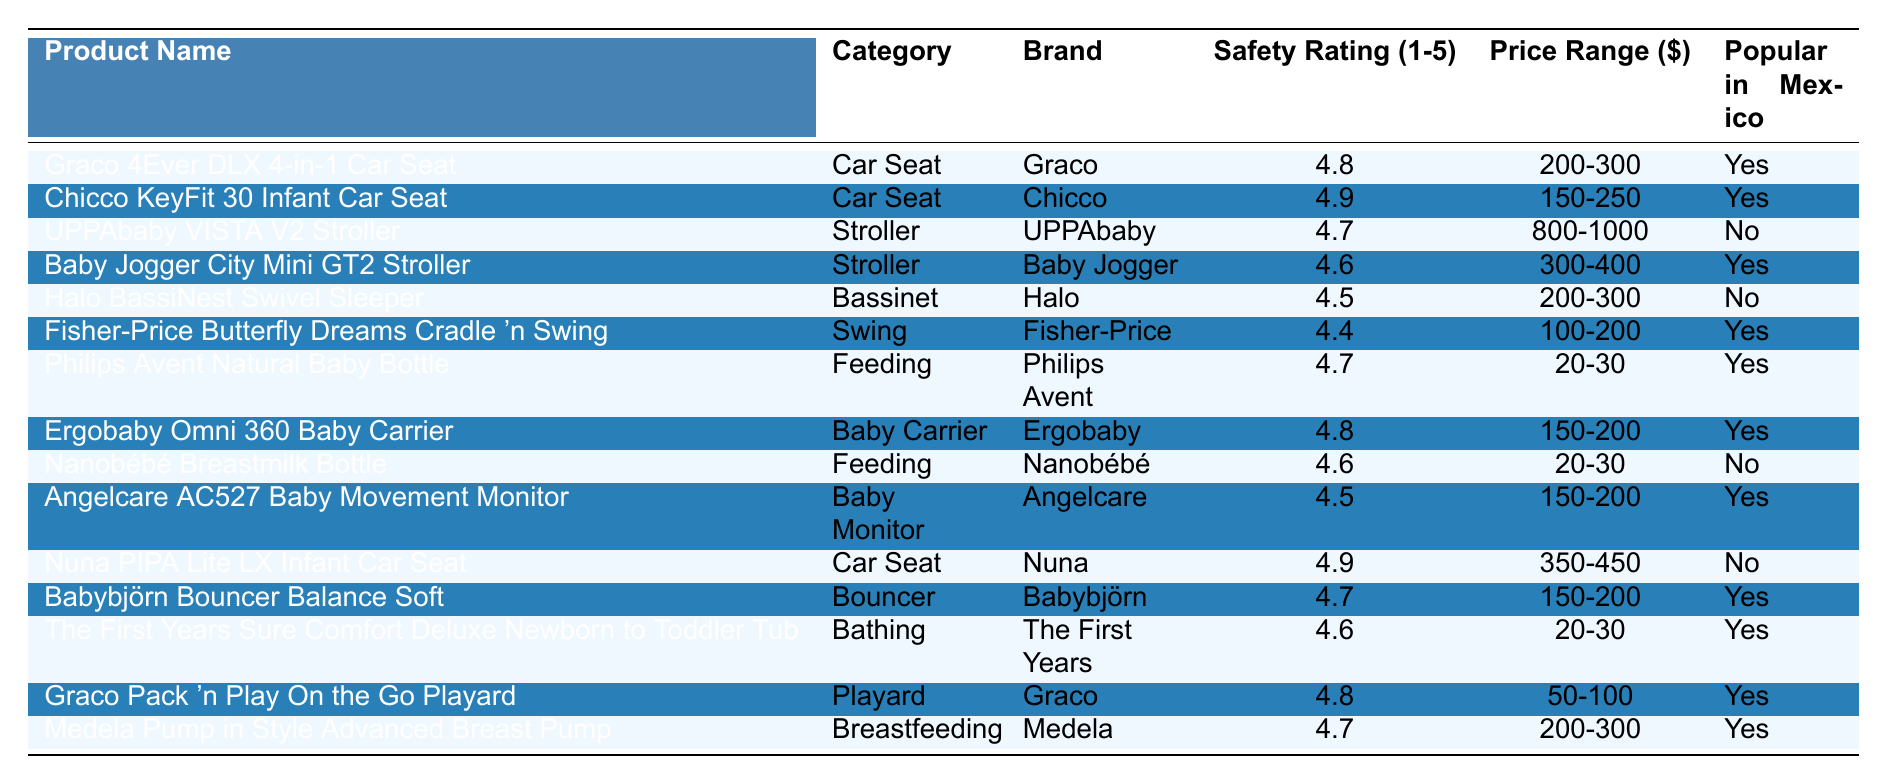What is the highest safety rating for baby products? The table shows multiple products with different safety ratings. Scanning through the "Safety Rating" column, the highest rating observed is 4.9, found with the Chicco KeyFit 30 Infant Car Seat and the Nuna PIPA Lite LX Infant Car Seat.
Answer: 4.9 Which product has the lowest safety rating and what is it? The "Safety Rating" column indicates that the product with the lowest safety rating is the Fisher-Price Butterfly Dreams Cradle 'n Swing with a rating of 4.4.
Answer: 4.4 How many products are popular in Mexico? By examining the "Popular in Mexico" column, we see that the products that have "Yes" listed are Graco 4Ever DLX 4-in-1 Car Seat, Chicco KeyFit 30 Infant Car Seat, Baby Jogger City Mini GT2 Stroller, Fisher-Price Butterfly Dreams Cradle 'n Swing, Philips Avent Natural Baby Bottle, Ergobaby Omni 360 Baby Carrier, Angelcare AC527 Baby Movement Monitor, Babybjörn Bouncer Balance Soft, The First Years Sure Comfort Deluxe Newborn to Toddler Tub, Graco Pack 'n Play On the Go Playard, and Medela Pump in Style Advanced Breast Pump. This amounts to a total of 11 products.
Answer: 11 What is the price range of the Ergobaby Omni 360 Baby Carrier? Looking at the table, the price range listed under the "Price Range" column for the Ergobaby Omni 360 Baby Carrier is 150-200.
Answer: 150-200 Are there any bassinet products that are popular in Mexico? Checking the "Popular in Mexico" column for the product in the "Bassinet" category, we find that the Halo BassiNest Swivel Sleeper has a "No" under popular in Mexico. Thus, there are no bassinets in the table that are popular in Mexico.
Answer: No What is the average safety rating of the car seats listed? To find the average safety rating of the car seats, identify the safety ratings: 4.8 (Graco), 4.9 (Chicco), and 4.9 (Nuna). The sum of these ratings is 4.8 + 4.9 + 4.9 = 14.6. Since there are 3 car seats, we divide by 3: 14.6 / 3 = 4.87, rounded to two decimal places gives 4.87.
Answer: 4.87 How many products fall within the price range of 200-300 dollars? Reviewing the "Price Range" column, we see that the following products fall within the specified range: Graco 4Ever DLX 4-in-1 Car Seat, Halo BassiNest Swivel Sleeper, and Medela Pump in Style Advanced Breast Pump. This totals to 3 products.
Answer: 3 Which brand has the most products listed in the table? Upon analyzing the table, we observe that Graco has 3 entries: Graco 4Ever DLX 4-in-1 Car Seat, Graco Pack 'n Play On the Go Playard, and an additional product classified as a car seat, making it the brand with the highest representation in the table.
Answer: Graco Which feeding product is not popular in Mexico? Checking the "Popular in Mexico" column, we find that the Nanobébé Breastmilk Bottle is marked as "No," indicating it is not popular in Mexico.
Answer: Nanobébé Breastmilk Bottle What is the price difference between the UPPAbaby VISTA V2 Stroller and the Baby Jogger City Mini GT2 Stroller? The price range for UPPAbaby VISTA V2 Stroller is 800-1000 and for Baby Jogger City Mini GT2 Stroller, it is 300-400. The difference can be expressed as: 1000 - 300 = 700 (upper bound) and 800 - 400 = 400 (lower bound). Hence, the price difference ranges from 400 to 700.
Answer: 400-700 